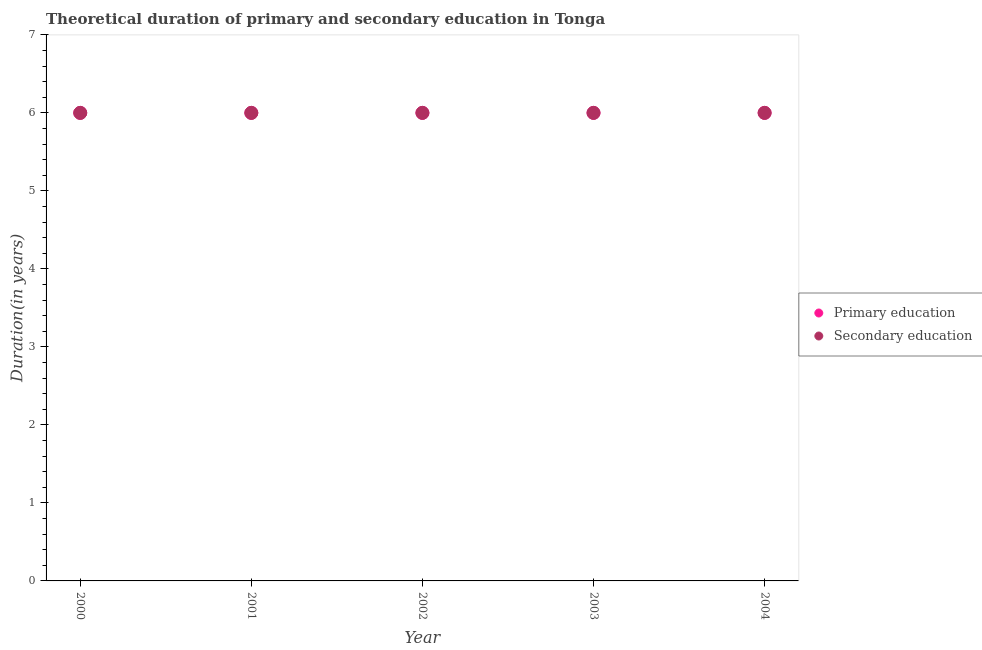How many different coloured dotlines are there?
Provide a succinct answer. 2. Is the number of dotlines equal to the number of legend labels?
Keep it short and to the point. Yes. What is the duration of secondary education in 2001?
Your answer should be very brief. 6. In which year was the duration of primary education maximum?
Offer a terse response. 2000. In which year was the duration of secondary education minimum?
Your answer should be very brief. 2000. What is the total duration of primary education in the graph?
Offer a terse response. 30. In the year 2002, what is the difference between the duration of primary education and duration of secondary education?
Your response must be concise. 0. In how many years, is the duration of primary education greater than 0.4 years?
Provide a short and direct response. 5. What is the ratio of the duration of primary education in 2001 to that in 2002?
Ensure brevity in your answer.  1. Is the difference between the duration of primary education in 2001 and 2003 greater than the difference between the duration of secondary education in 2001 and 2003?
Your answer should be very brief. No. What is the difference between the highest and the lowest duration of primary education?
Give a very brief answer. 0. Is the duration of secondary education strictly greater than the duration of primary education over the years?
Provide a succinct answer. No. Is the duration of secondary education strictly less than the duration of primary education over the years?
Provide a succinct answer. No. How many years are there in the graph?
Your response must be concise. 5. What is the difference between two consecutive major ticks on the Y-axis?
Your answer should be very brief. 1. Are the values on the major ticks of Y-axis written in scientific E-notation?
Make the answer very short. No. How many legend labels are there?
Offer a terse response. 2. How are the legend labels stacked?
Offer a terse response. Vertical. What is the title of the graph?
Your answer should be compact. Theoretical duration of primary and secondary education in Tonga. What is the label or title of the X-axis?
Offer a terse response. Year. What is the label or title of the Y-axis?
Your answer should be compact. Duration(in years). What is the Duration(in years) in Primary education in 2000?
Give a very brief answer. 6. What is the Duration(in years) of Secondary education in 2000?
Make the answer very short. 6. What is the Duration(in years) of Primary education in 2001?
Give a very brief answer. 6. What is the Duration(in years) of Secondary education in 2001?
Make the answer very short. 6. What is the Duration(in years) in Primary education in 2002?
Keep it short and to the point. 6. What is the Duration(in years) in Secondary education in 2002?
Offer a very short reply. 6. What is the Duration(in years) of Primary education in 2003?
Provide a succinct answer. 6. What is the Duration(in years) in Primary education in 2004?
Your response must be concise. 6. What is the Duration(in years) in Secondary education in 2004?
Provide a succinct answer. 6. Across all years, what is the maximum Duration(in years) in Primary education?
Your response must be concise. 6. Across all years, what is the maximum Duration(in years) in Secondary education?
Keep it short and to the point. 6. Across all years, what is the minimum Duration(in years) in Primary education?
Your response must be concise. 6. Across all years, what is the minimum Duration(in years) in Secondary education?
Keep it short and to the point. 6. What is the total Duration(in years) of Primary education in the graph?
Your answer should be compact. 30. What is the total Duration(in years) of Secondary education in the graph?
Your answer should be very brief. 30. What is the difference between the Duration(in years) in Primary education in 2000 and that in 2001?
Offer a terse response. 0. What is the difference between the Duration(in years) in Primary education in 2000 and that in 2002?
Provide a succinct answer. 0. What is the difference between the Duration(in years) of Secondary education in 2000 and that in 2003?
Your answer should be compact. 0. What is the difference between the Duration(in years) of Primary education in 2000 and that in 2004?
Make the answer very short. 0. What is the difference between the Duration(in years) of Secondary education in 2000 and that in 2004?
Offer a very short reply. 0. What is the difference between the Duration(in years) in Primary education in 2001 and that in 2002?
Your answer should be compact. 0. What is the difference between the Duration(in years) in Primary education in 2001 and that in 2003?
Give a very brief answer. 0. What is the difference between the Duration(in years) of Secondary education in 2001 and that in 2003?
Give a very brief answer. 0. What is the difference between the Duration(in years) in Primary education in 2002 and that in 2003?
Your response must be concise. 0. What is the difference between the Duration(in years) in Primary education in 2002 and that in 2004?
Keep it short and to the point. 0. What is the difference between the Duration(in years) in Primary education in 2000 and the Duration(in years) in Secondary education in 2001?
Offer a terse response. 0. What is the difference between the Duration(in years) in Primary education in 2000 and the Duration(in years) in Secondary education in 2004?
Ensure brevity in your answer.  0. What is the difference between the Duration(in years) in Primary education in 2001 and the Duration(in years) in Secondary education in 2002?
Your answer should be compact. 0. What is the difference between the Duration(in years) in Primary education in 2001 and the Duration(in years) in Secondary education in 2004?
Ensure brevity in your answer.  0. What is the difference between the Duration(in years) in Primary education in 2002 and the Duration(in years) in Secondary education in 2004?
Your response must be concise. 0. What is the average Duration(in years) of Primary education per year?
Ensure brevity in your answer.  6. What is the average Duration(in years) of Secondary education per year?
Offer a terse response. 6. In the year 2000, what is the difference between the Duration(in years) in Primary education and Duration(in years) in Secondary education?
Offer a terse response. 0. In the year 2002, what is the difference between the Duration(in years) in Primary education and Duration(in years) in Secondary education?
Your answer should be very brief. 0. In the year 2003, what is the difference between the Duration(in years) of Primary education and Duration(in years) of Secondary education?
Make the answer very short. 0. In the year 2004, what is the difference between the Duration(in years) in Primary education and Duration(in years) in Secondary education?
Give a very brief answer. 0. What is the ratio of the Duration(in years) in Primary education in 2000 to that in 2001?
Provide a succinct answer. 1. What is the ratio of the Duration(in years) in Secondary education in 2000 to that in 2001?
Provide a succinct answer. 1. What is the ratio of the Duration(in years) in Primary education in 2000 to that in 2002?
Ensure brevity in your answer.  1. What is the ratio of the Duration(in years) of Secondary education in 2000 to that in 2002?
Your answer should be compact. 1. What is the ratio of the Duration(in years) in Primary education in 2001 to that in 2002?
Make the answer very short. 1. What is the ratio of the Duration(in years) of Primary education in 2001 to that in 2003?
Keep it short and to the point. 1. What is the ratio of the Duration(in years) of Secondary education in 2001 to that in 2003?
Provide a succinct answer. 1. What is the ratio of the Duration(in years) in Primary education in 2001 to that in 2004?
Make the answer very short. 1. What is the ratio of the Duration(in years) in Secondary education in 2002 to that in 2003?
Your answer should be very brief. 1. What is the ratio of the Duration(in years) in Secondary education in 2002 to that in 2004?
Ensure brevity in your answer.  1. What is the ratio of the Duration(in years) of Secondary education in 2003 to that in 2004?
Provide a short and direct response. 1. What is the difference between the highest and the second highest Duration(in years) of Secondary education?
Offer a terse response. 0. 